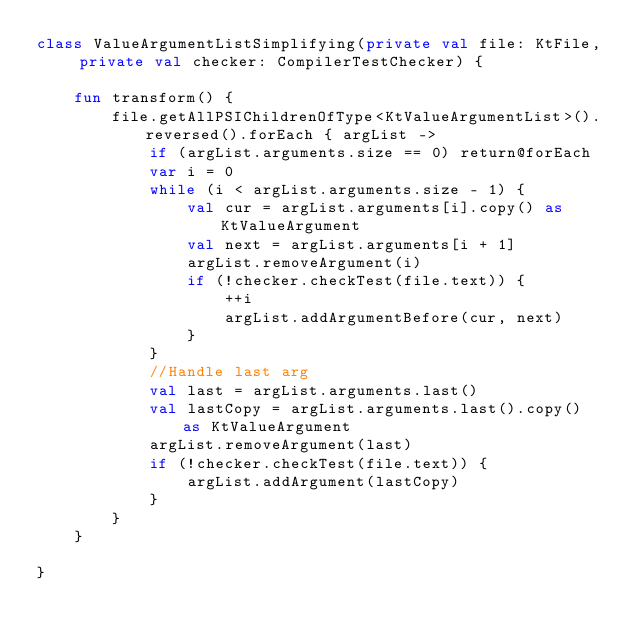Convert code to text. <code><loc_0><loc_0><loc_500><loc_500><_Kotlin_>class ValueArgumentListSimplifying(private val file: KtFile, private val checker: CompilerTestChecker) {

    fun transform() {
        file.getAllPSIChildrenOfType<KtValueArgumentList>().reversed().forEach { argList ->
            if (argList.arguments.size == 0) return@forEach
            var i = 0
            while (i < argList.arguments.size - 1) {
                val cur = argList.arguments[i].copy() as KtValueArgument
                val next = argList.arguments[i + 1]
                argList.removeArgument(i)
                if (!checker.checkTest(file.text)) {
                    ++i
                    argList.addArgumentBefore(cur, next)
                }
            }
            //Handle last arg
            val last = argList.arguments.last()
            val lastCopy = argList.arguments.last().copy() as KtValueArgument
            argList.removeArgument(last)
            if (!checker.checkTest(file.text)) {
                argList.addArgument(lastCopy)
            }
        }
    }

}</code> 